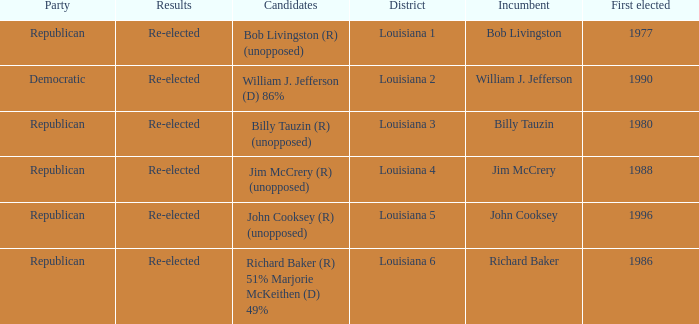How many applicants were elected first in 1980? 1.0. 